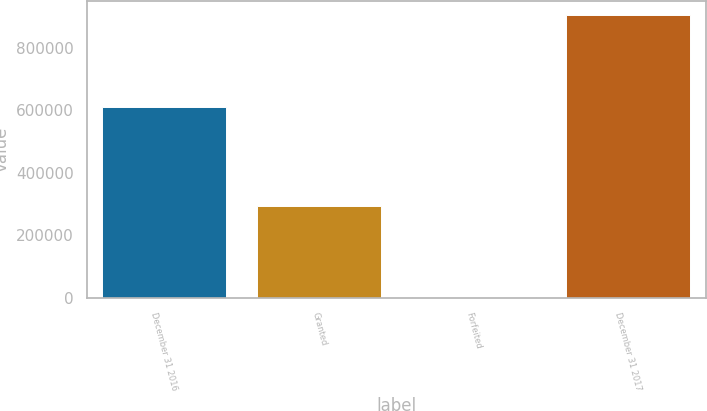Convert chart to OTSL. <chart><loc_0><loc_0><loc_500><loc_500><bar_chart><fcel>December 31 2016<fcel>Granted<fcel>Forfeited<fcel>December 31 2017<nl><fcel>610371<fcel>294584<fcel>1430<fcel>903525<nl></chart> 